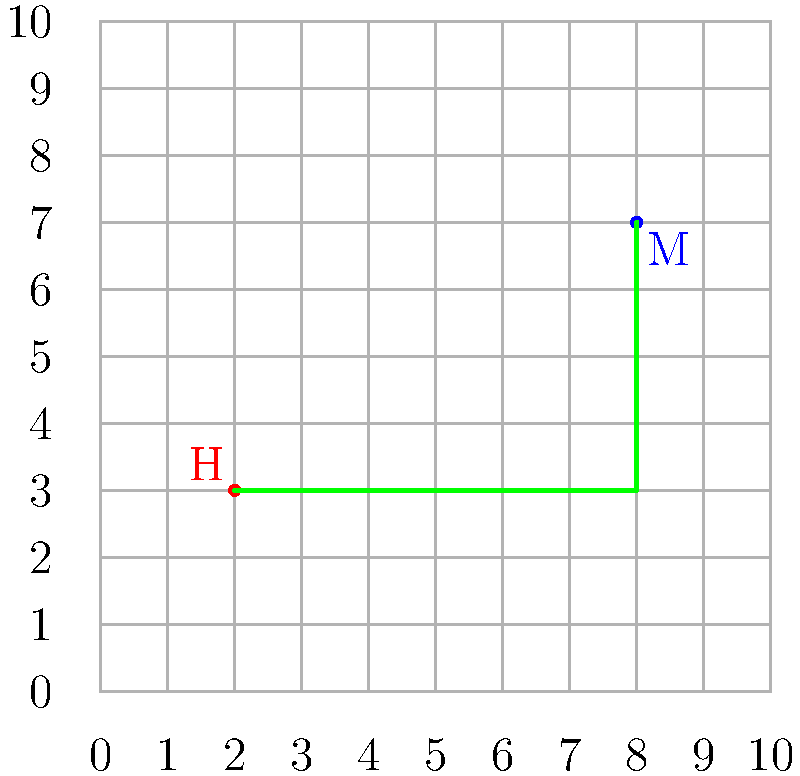A medical evacuation helicopter (H) needs to transport a patient from its current location to a medical facility (M) on a grid map. The helicopter can only move horizontally or vertically. Given the coordinates of the helicopter (2,3) and the medical facility (8,7), what is the minimum distance the helicopter must travel to reach the facility? To solve this problem, we'll follow these steps:

1) First, we need to understand that the helicopter can only move horizontally or vertically. This means we're dealing with what's known as "Manhattan distance" or "L1 norm".

2) The formula for Manhattan distance is:
   $$ d = |x_2 - x_1| + |y_2 - y_1| $$
   where $(x_1, y_1)$ is the starting point and $(x_2, y_2)$ is the ending point.

3) In our case:
   - The helicopter's coordinates (H) are $(x_1, y_1) = (2, 3)$
   - The medical facility's coordinates (M) are $(x_2, y_2) = (8, 7)$

4) Let's plug these into our formula:
   $$ d = |8 - 2| + |7 - 3| $$

5) Simplify:
   $$ d = |6| + |4| $$

6) Calculate:
   $$ d = 6 + 4 = 10 $$

Therefore, the minimum distance the helicopter must travel is 10 grid units.

Note: On the grid, this could be achieved by moving 6 units right and then 4 units up, or 4 units up and then 6 units right, or any combination that totals 10 moves right and up.
Answer: 10 grid units 